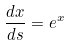<formula> <loc_0><loc_0><loc_500><loc_500>\frac { d x } { d s } = e ^ { x }</formula> 